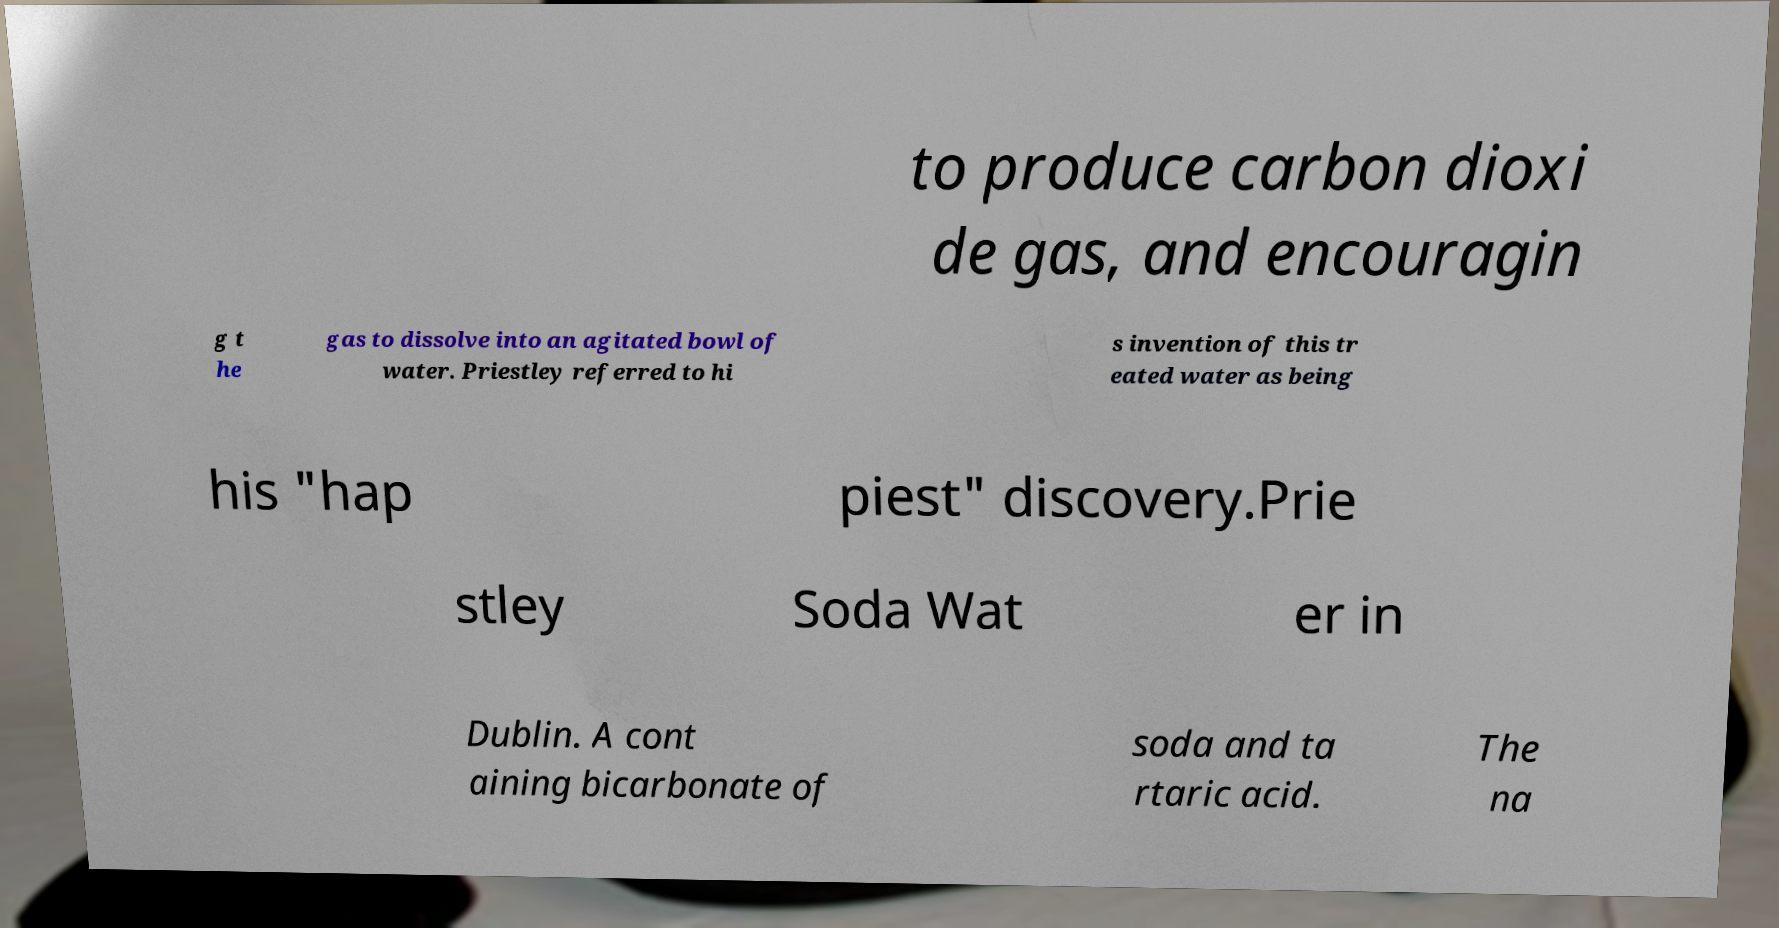Could you extract and type out the text from this image? to produce carbon dioxi de gas, and encouragin g t he gas to dissolve into an agitated bowl of water. Priestley referred to hi s invention of this tr eated water as being his "hap piest" discovery.Prie stley Soda Wat er in Dublin. A cont aining bicarbonate of soda and ta rtaric acid. The na 